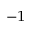<formula> <loc_0><loc_0><loc_500><loc_500>^ { - 1 }</formula> 